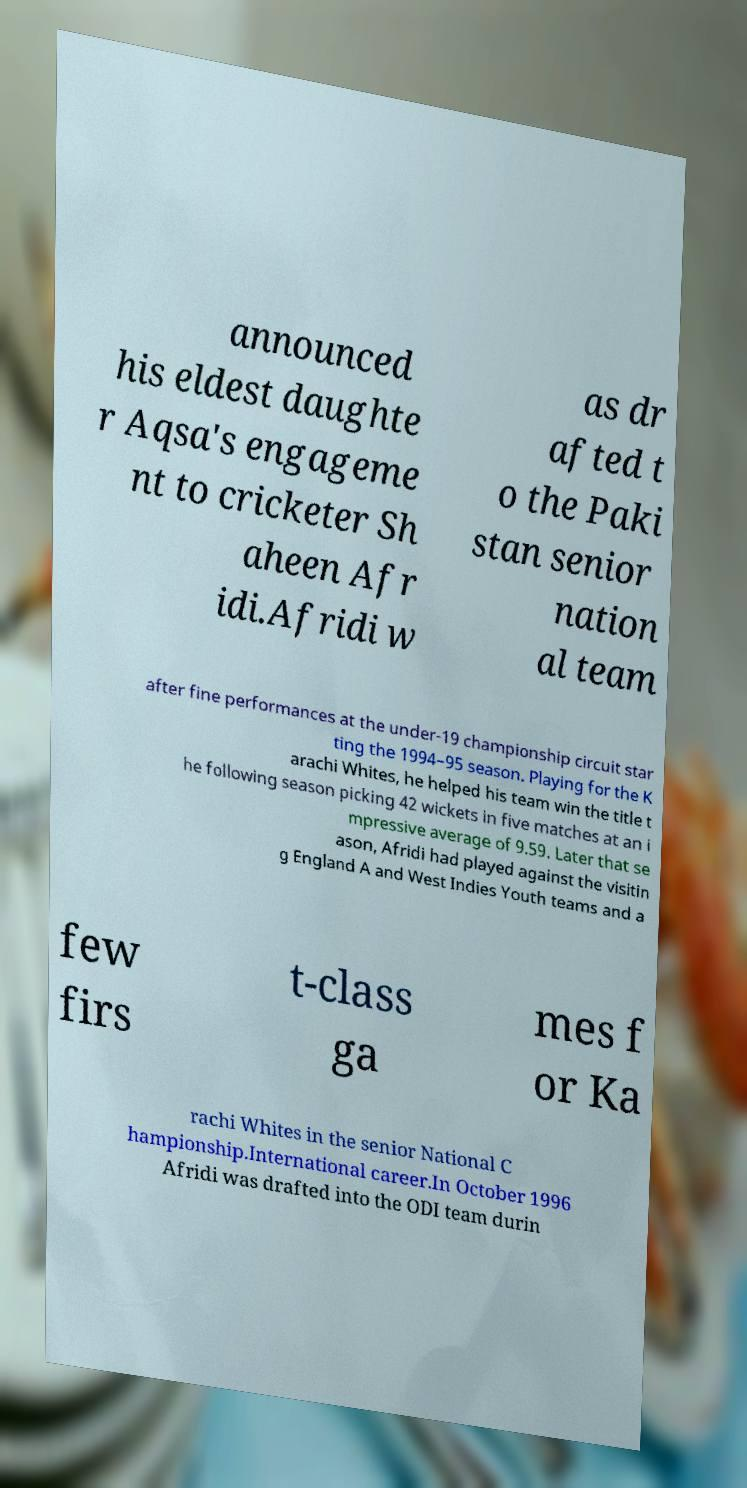I need the written content from this picture converted into text. Can you do that? announced his eldest daughte r Aqsa's engageme nt to cricketer Sh aheen Afr idi.Afridi w as dr afted t o the Paki stan senior nation al team after fine performances at the under-19 championship circuit star ting the 1994–95 season. Playing for the K arachi Whites, he helped his team win the title t he following season picking 42 wickets in five matches at an i mpressive average of 9.59. Later that se ason, Afridi had played against the visitin g England A and West Indies Youth teams and a few firs t-class ga mes f or Ka rachi Whites in the senior National C hampionship.International career.In October 1996 Afridi was drafted into the ODI team durin 